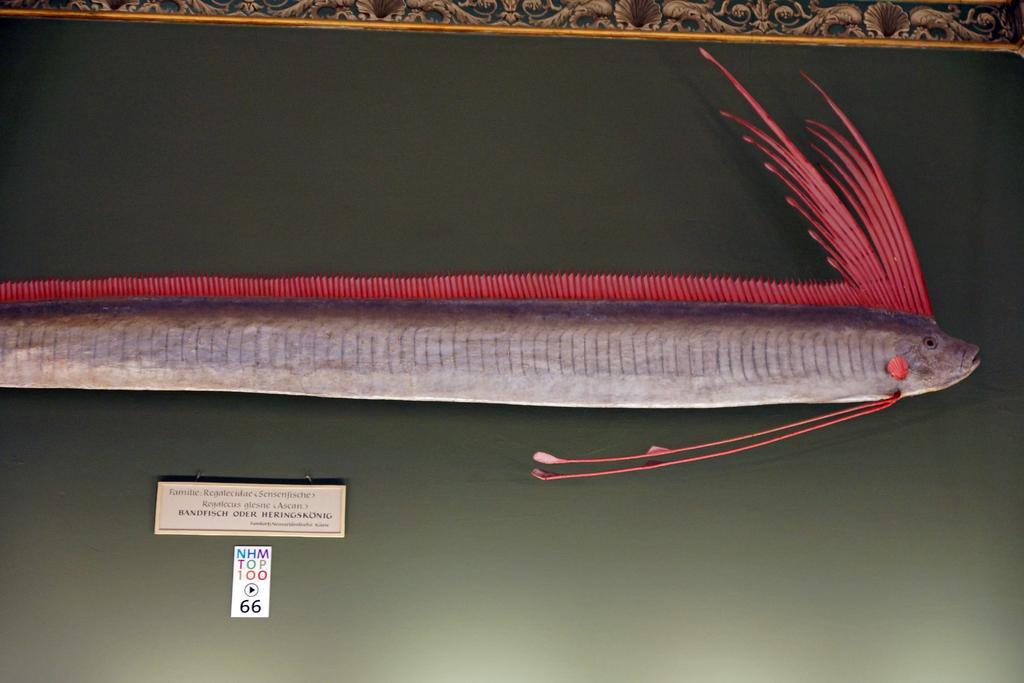Can you describe this image briefly? This image consists of a picture frame with an art of fish and there is a text on it. 